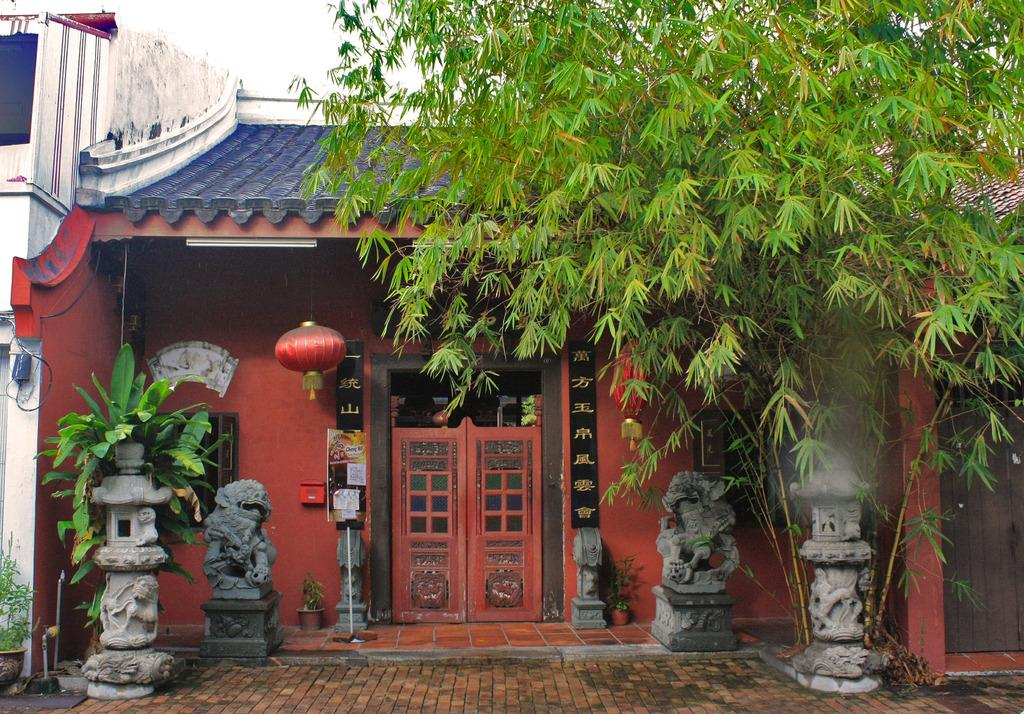What type of natural element can be seen in the image? There is a tree in the image. What other types of vegetation are present in the image? There are plants in the image. What type of structure is visible in the image? There is a house in the image. What type of artwork can be seen in the image? There are sculptures in the image. What surface is visible beneath the objects in the image? The floor is visible in the image. What part of the natural environment is visible in the image? The sky is visible in the image. Can you tell me how much milk is being poured into the stove in the image? There is no milk or stove present in the image. What type of creature is shown interacting with the plants in the image? There is no creature shown interacting with the plants in the image; only the tree, plants, house, sculptures, floor, and sky are present. 